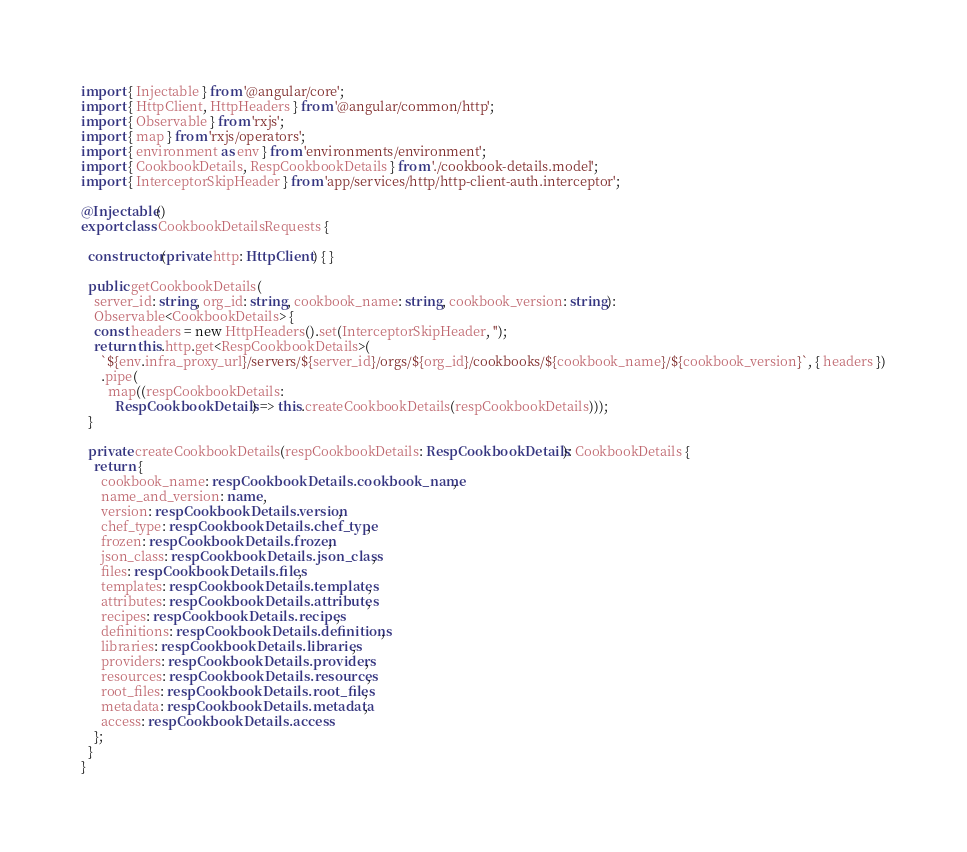<code> <loc_0><loc_0><loc_500><loc_500><_TypeScript_>import { Injectable } from '@angular/core';
import { HttpClient, HttpHeaders } from '@angular/common/http';
import { Observable } from 'rxjs';
import { map } from 'rxjs/operators';
import { environment as env } from 'environments/environment';
import { CookbookDetails, RespCookbookDetails } from './cookbook-details.model';
import { InterceptorSkipHeader } from 'app/services/http/http-client-auth.interceptor';

@Injectable()
export class CookbookDetailsRequests {

  constructor(private http: HttpClient) { }

  public getCookbookDetails(
    server_id: string, org_id: string, cookbook_name: string, cookbook_version: string):
    Observable<CookbookDetails> {
    const headers = new HttpHeaders().set(InterceptorSkipHeader, '');
    return this.http.get<RespCookbookDetails>(
      `${env.infra_proxy_url}/servers/${server_id}/orgs/${org_id}/cookbooks/${cookbook_name}/${cookbook_version}`, { headers })
      .pipe(
        map((respCookbookDetails:
          RespCookbookDetails) => this.createCookbookDetails(respCookbookDetails)));
  }

  private createCookbookDetails(respCookbookDetails: RespCookbookDetails): CookbookDetails {
    return {
      cookbook_name: respCookbookDetails.cookbook_name,
      name_and_version: name,
      version: respCookbookDetails.version,
      chef_type: respCookbookDetails.chef_type,
      frozen: respCookbookDetails.frozen,
      json_class: respCookbookDetails.json_class,
      files: respCookbookDetails.files,
      templates: respCookbookDetails.templates,
      attributes: respCookbookDetails.attributes,
      recipes: respCookbookDetails.recipes,
      definitions: respCookbookDetails.definitions,
      libraries: respCookbookDetails.libraries,
      providers: respCookbookDetails.providers,
      resources: respCookbookDetails.resources,
      root_files: respCookbookDetails.root_files,
      metadata: respCookbookDetails.metadata,
      access: respCookbookDetails.access
    };
  }
}
</code> 